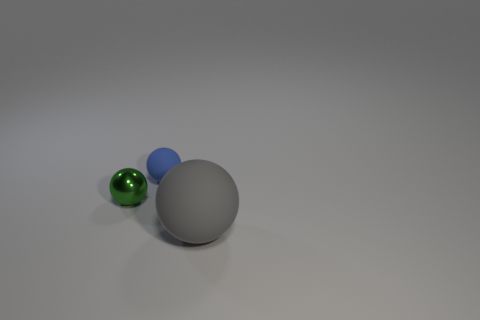Add 2 gray rubber balls. How many objects exist? 5 Subtract 0 red blocks. How many objects are left? 3 Subtract all big matte balls. Subtract all large things. How many objects are left? 1 Add 2 blue spheres. How many blue spheres are left? 3 Add 1 small green balls. How many small green balls exist? 2 